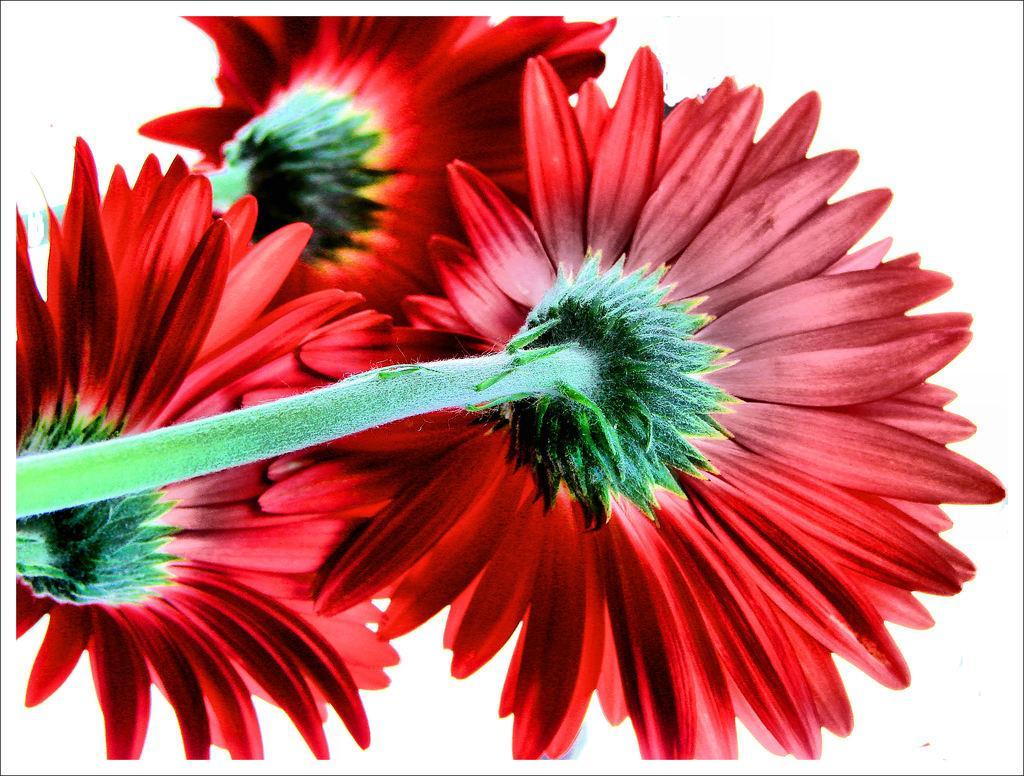Describe this image in one or two sentences. In this picture we can see flowers with stems and in the background we can see white color. 